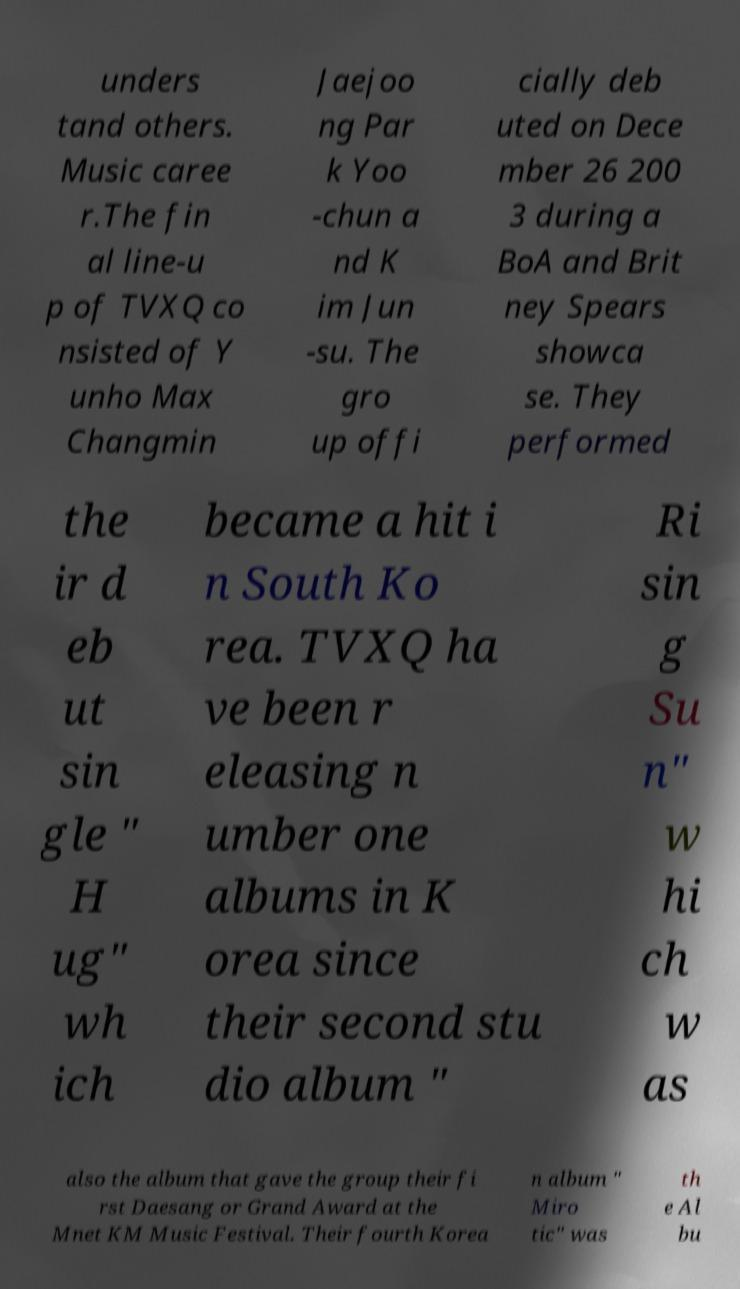There's text embedded in this image that I need extracted. Can you transcribe it verbatim? unders tand others. Music caree r.The fin al line-u p of TVXQ co nsisted of Y unho Max Changmin Jaejoo ng Par k Yoo -chun a nd K im Jun -su. The gro up offi cially deb uted on Dece mber 26 200 3 during a BoA and Brit ney Spears showca se. They performed the ir d eb ut sin gle " H ug" wh ich became a hit i n South Ko rea. TVXQ ha ve been r eleasing n umber one albums in K orea since their second stu dio album " Ri sin g Su n" w hi ch w as also the album that gave the group their fi rst Daesang or Grand Award at the Mnet KM Music Festival. Their fourth Korea n album " Miro tic" was th e Al bu 